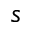Convert formula to latex. <formula><loc_0><loc_0><loc_500><loc_500>s</formula> 